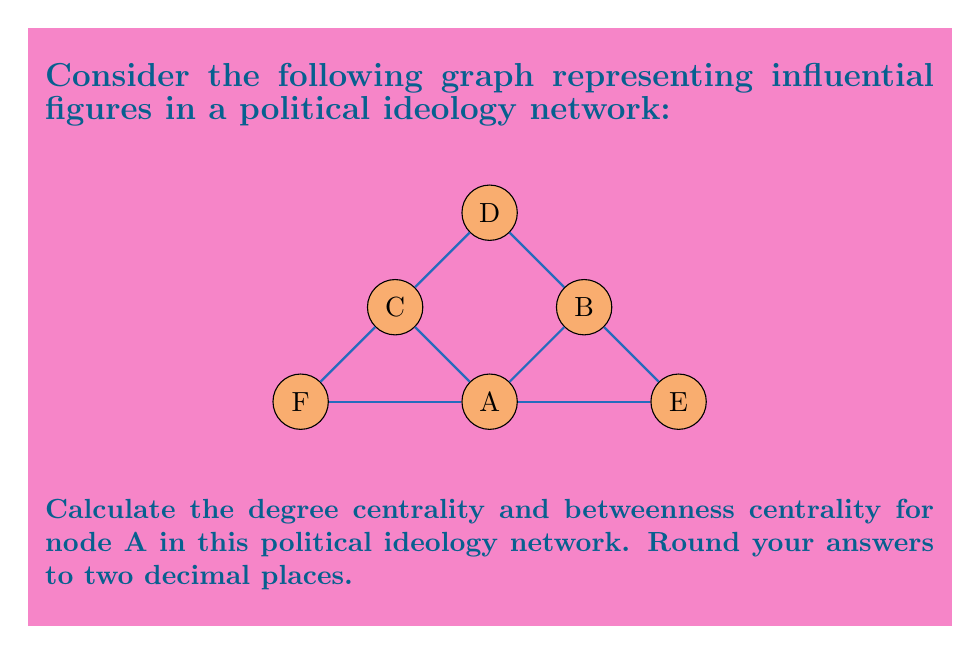What is the answer to this math problem? To solve this problem, we'll calculate both the degree centrality and betweenness centrality for node A.

1. Degree Centrality:
   Degree centrality is the number of direct connections a node has, divided by the maximum possible connections.
   
   - Node A has 4 direct connections (to B, C, E, and F).
   - The graph has 6 nodes in total, so the maximum possible connections is 5.
   - Degree centrality = $\frac{4}{5} = 0.8$

2. Betweenness Centrality:
   Betweenness centrality measures the extent to which a node lies on the shortest paths between other nodes.

   Step 1: Identify all shortest paths:
   B-A-C, B-A-E, B-A-F, C-A-E, C-A-F, D-B-A-C, D-B-A-E, D-B-A-F, E-A-F

   Step 2: Count paths that go through A:
   B-A-C, B-A-E, B-A-F, C-A-E, C-A-F, D-B-A-C (1/2), D-B-A-E (1/2), D-B-A-F (1/2), E-A-F
   Total: 7.5 paths

   Step 3: Calculate the betweenness centrality:
   $$\text{Betweenness Centrality} = \frac{2 \times \text{number of shortest paths through A}}{\text{total number of node pairs}}$$
   $$= \frac{2 \times 7.5}{6 \times 5} = \frac{15}{30} = 0.5$$

Therefore, the degree centrality for node A is 0.80, and the betweenness centrality is 0.50.
Answer: Degree centrality: 0.80; Betweenness centrality: 0.50 